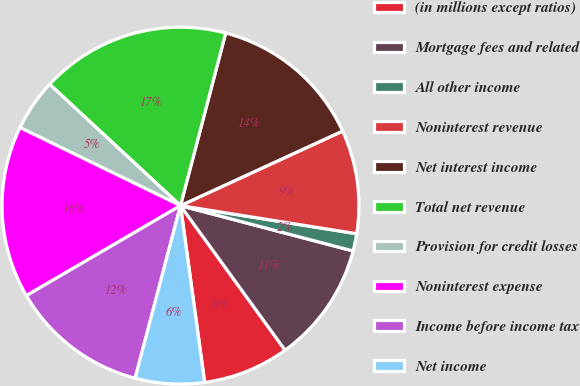<chart> <loc_0><loc_0><loc_500><loc_500><pie_chart><fcel>(in millions except ratios)<fcel>Mortgage fees and related<fcel>All other income<fcel>Noninterest revenue<fcel>Net interest income<fcel>Total net revenue<fcel>Provision for credit losses<fcel>Noninterest expense<fcel>Income before income tax<fcel>Net income<nl><fcel>7.81%<fcel>10.94%<fcel>1.57%<fcel>9.38%<fcel>14.06%<fcel>17.18%<fcel>4.69%<fcel>15.62%<fcel>12.5%<fcel>6.25%<nl></chart> 